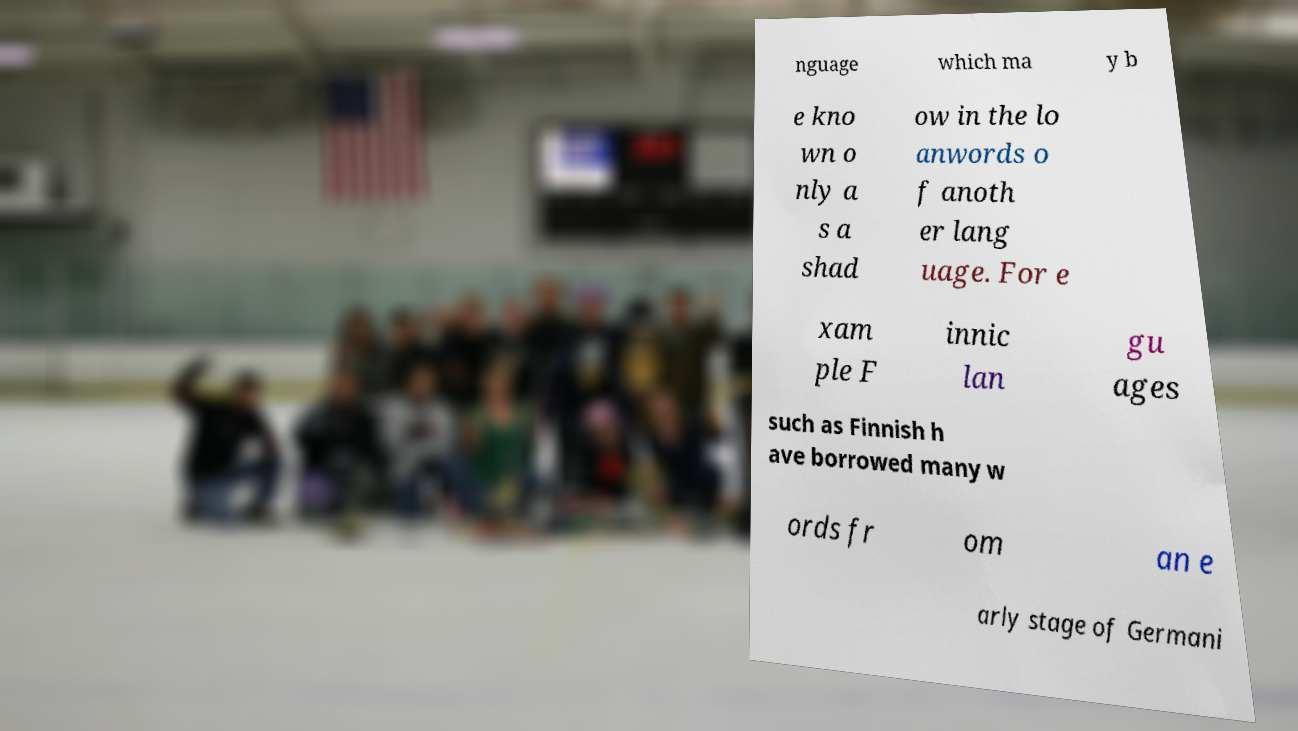Can you read and provide the text displayed in the image?This photo seems to have some interesting text. Can you extract and type it out for me? nguage which ma y b e kno wn o nly a s a shad ow in the lo anwords o f anoth er lang uage. For e xam ple F innic lan gu ages such as Finnish h ave borrowed many w ords fr om an e arly stage of Germani 